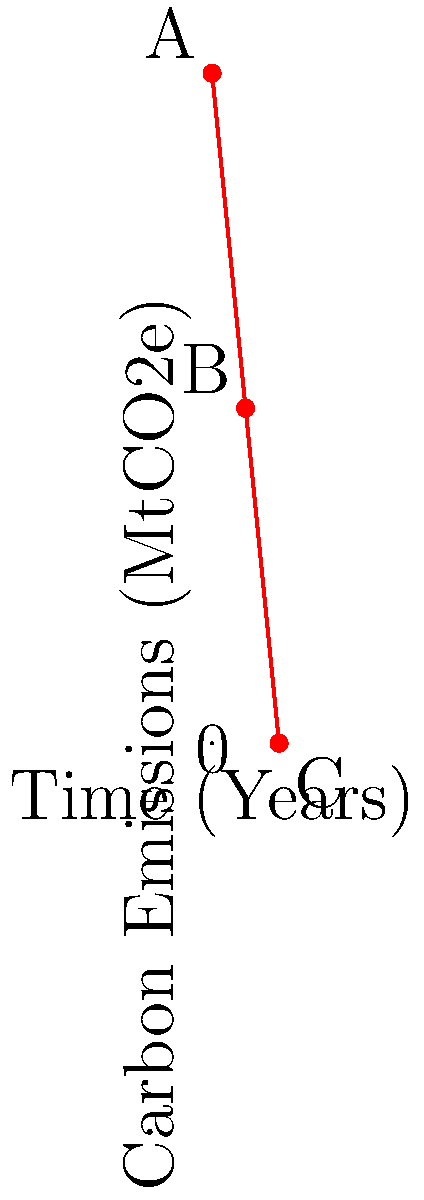A company sets a linear carbon emission reduction target as shown in the graph. Point A represents the starting emissions, point B the midpoint, and point C the final target. If the x-axis represents years and the y-axis represents emissions in MtCO2e (Million tonnes of CO2 equivalent), what is the annual rate of emission reduction? To find the annual rate of emission reduction, we need to follow these steps:

1. Identify the total time period:
   The x-axis spans from 0 to 10 years, so the total time period is 10 years.

2. Calculate the total emission reduction:
   Initial emissions (point A) = 100 MtCO2e
   Final emissions (point C) = 0 MtCO2e
   Total reduction = 100 - 0 = 100 MtCO2e

3. Calculate the annual rate of reduction:
   Annual rate = Total reduction / Number of years
   $$ \text{Annual rate} = \frac{100 \text{ MtCO2e}}{10 \text{ years}} = 10 \text{ MtCO2e/year} $$

4. Verify with the midpoint (point B):
   At 5 years, emissions should be 50 MtCO2e
   $100 \text{ MtCO2e} - (5 \text{ years} \times 10 \text{ MtCO2e/year}) = 50 \text{ MtCO2e}$

This confirms that the reduction rate is constant and linear.
Answer: 10 MtCO2e/year 